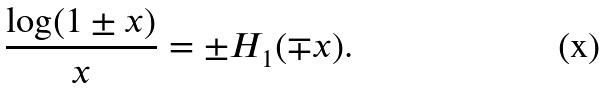Convert formula to latex. <formula><loc_0><loc_0><loc_500><loc_500>\frac { \log ( 1 \pm x ) } { x } = \pm H _ { 1 } ( \mp x ) .</formula> 